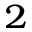Convert formula to latex. <formula><loc_0><loc_0><loc_500><loc_500>^ { 2 }</formula> 